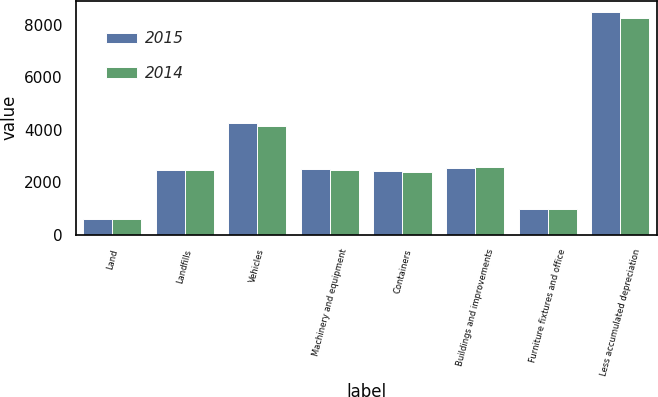<chart> <loc_0><loc_0><loc_500><loc_500><stacked_bar_chart><ecel><fcel>Land<fcel>Landfills<fcel>Vehicles<fcel>Machinery and equipment<fcel>Containers<fcel>Buildings and improvements<fcel>Furniture fixtures and office<fcel>Less accumulated depreciation<nl><fcel>2015<fcel>592<fcel>2484.5<fcel>4257<fcel>2499<fcel>2426<fcel>2546<fcel>993<fcel>8495<nl><fcel>2014<fcel>611<fcel>2484.5<fcel>4131<fcel>2470<fcel>2377<fcel>2588<fcel>985<fcel>8278<nl></chart> 